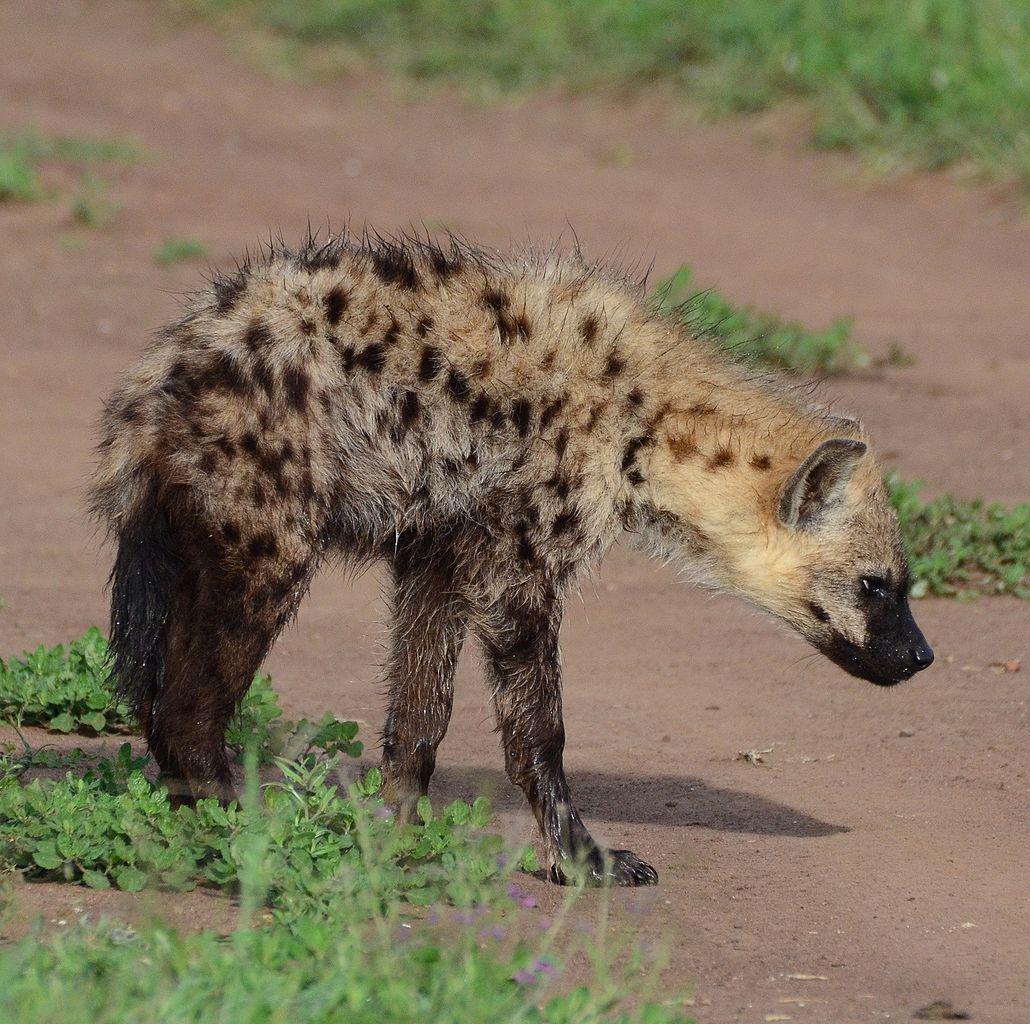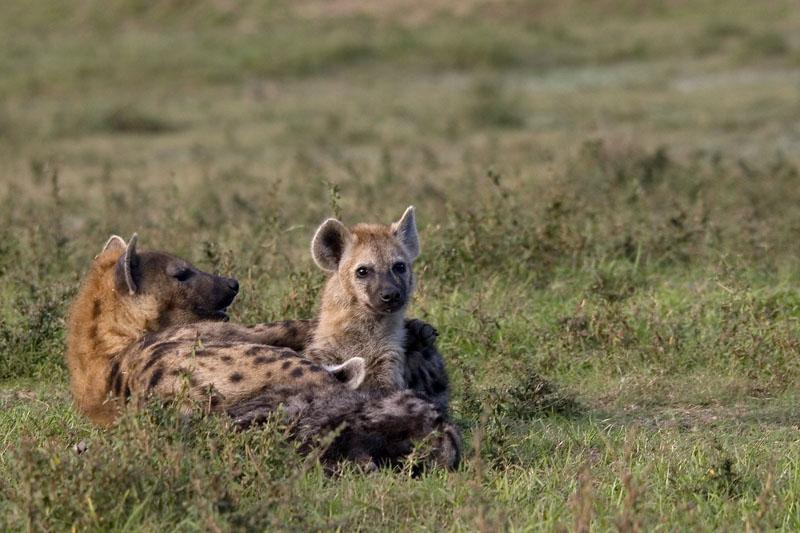The first image is the image on the left, the second image is the image on the right. Given the left and right images, does the statement "More animals are in the image on the right." hold true? Answer yes or no. Yes. The first image is the image on the left, the second image is the image on the right. Examine the images to the left and right. Is the description "The left image shows one hyena on all fours with its head lowered and to the right." accurate? Answer yes or no. Yes. 